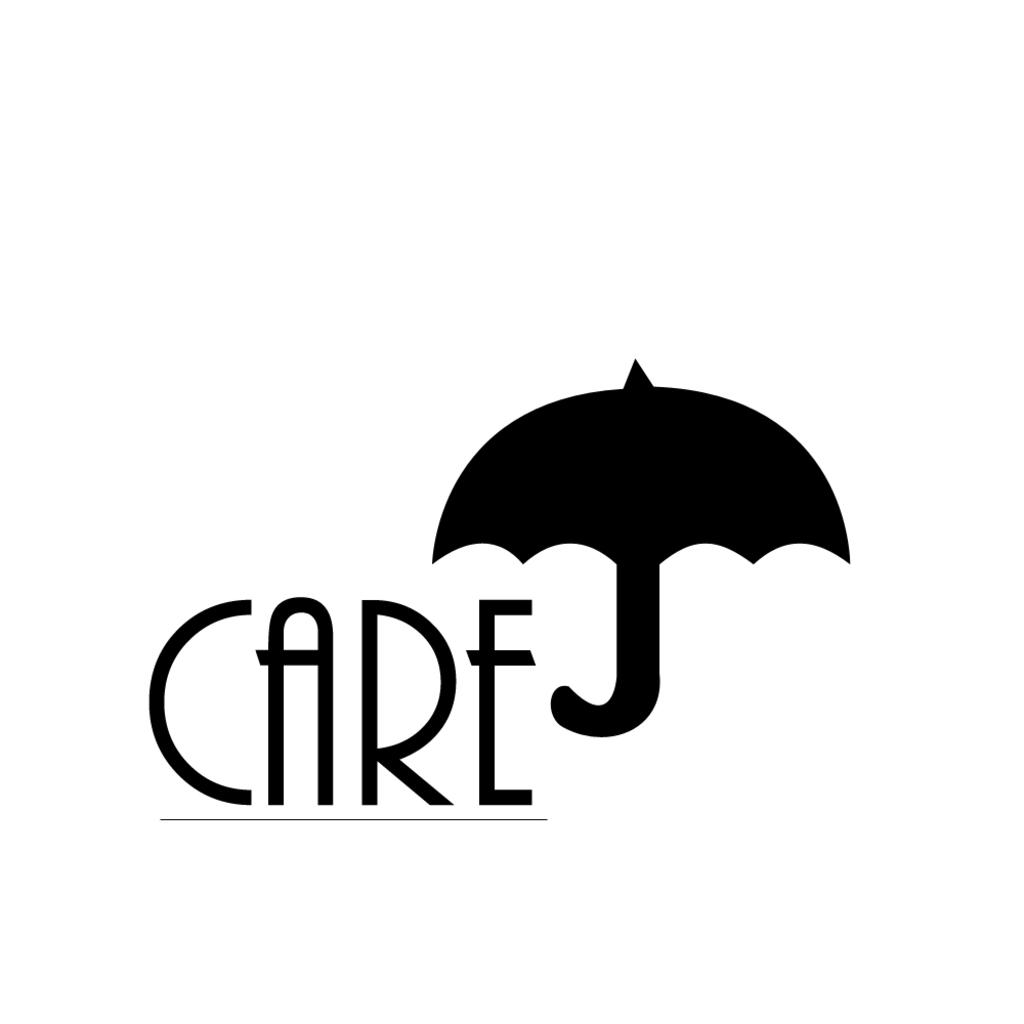What can be found in the image that contains written information? There is some text in the image. What object is present in the image that can provide shade or protection from rain? There is an umbrella in the image. What color is the background of the image? The background of the image is white. How many chickens are sitting on the beam in the image? There are no chickens or beams present in the image. What type of bean is being used as a prop in the image? There are no beans present in the image. 